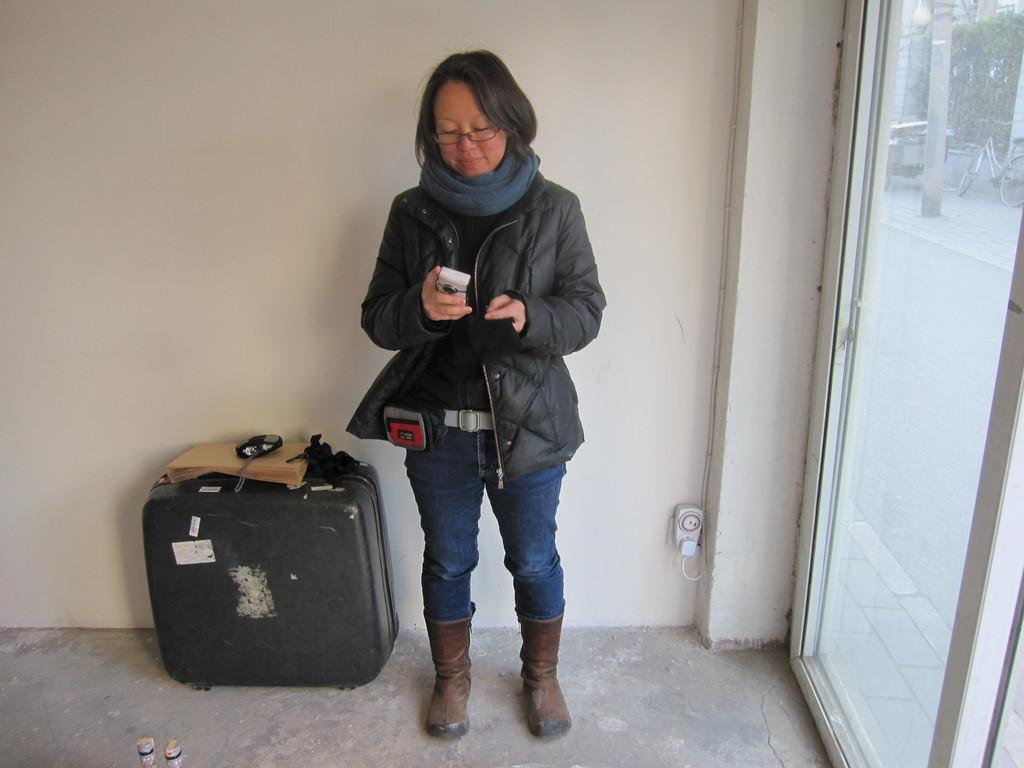Who is present in the image? There is a woman in the image. What is the woman doing in the image? The woman is standing on the floor and holding a camera in her hands. What other objects can be seen in the image? There is a briefcase in the image. What can be seen in the background of the image? There is a wall and a glass door in the background of the image. What type of bun is the woman using to take pictures in the image? There is no bun present in the image, and the woman is using a camera to take pictures. Can you see any oil spills on the floor in the image? There is no mention of oil spills or any liquid on the floor in the image. Is the woman standing near the sea in the image? There is no indication of the sea or any body of water in the image. 